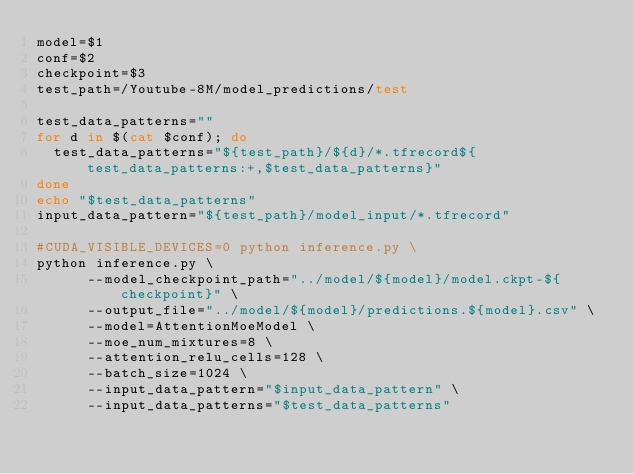Convert code to text. <code><loc_0><loc_0><loc_500><loc_500><_Bash_>model=$1
conf=$2
checkpoint=$3
test_path=/Youtube-8M/model_predictions/test

test_data_patterns=""
for d in $(cat $conf); do
  test_data_patterns="${test_path}/${d}/*.tfrecord${test_data_patterns:+,$test_data_patterns}"
done
echo "$test_data_patterns"
input_data_pattern="${test_path}/model_input/*.tfrecord"

#CUDA_VISIBLE_DEVICES=0 python inference.py \
python inference.py \
      --model_checkpoint_path="../model/${model}/model.ckpt-${checkpoint}" \
      --output_file="../model/${model}/predictions.${model}.csv" \
      --model=AttentionMoeModel \
      --moe_num_mixtures=8 \
      --attention_relu_cells=128 \
      --batch_size=1024 \
      --input_data_pattern="$input_data_pattern" \
      --input_data_patterns="$test_data_patterns"
</code> 